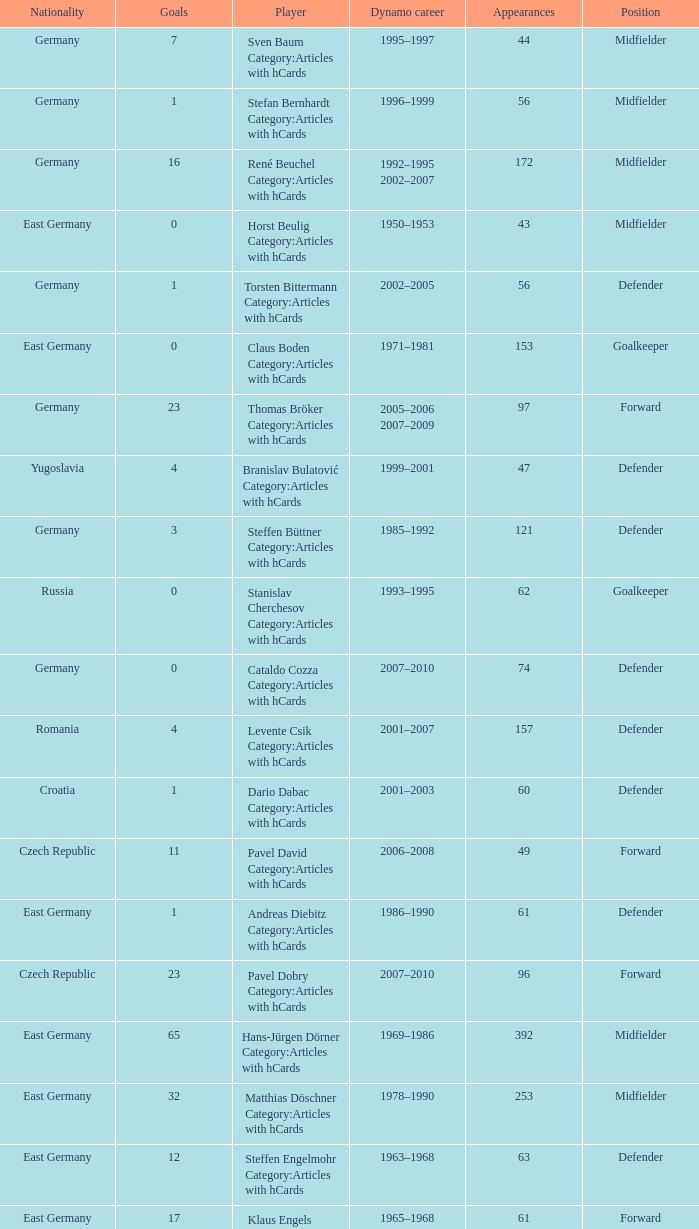What was the position of the player with 57 goals? Forward. 